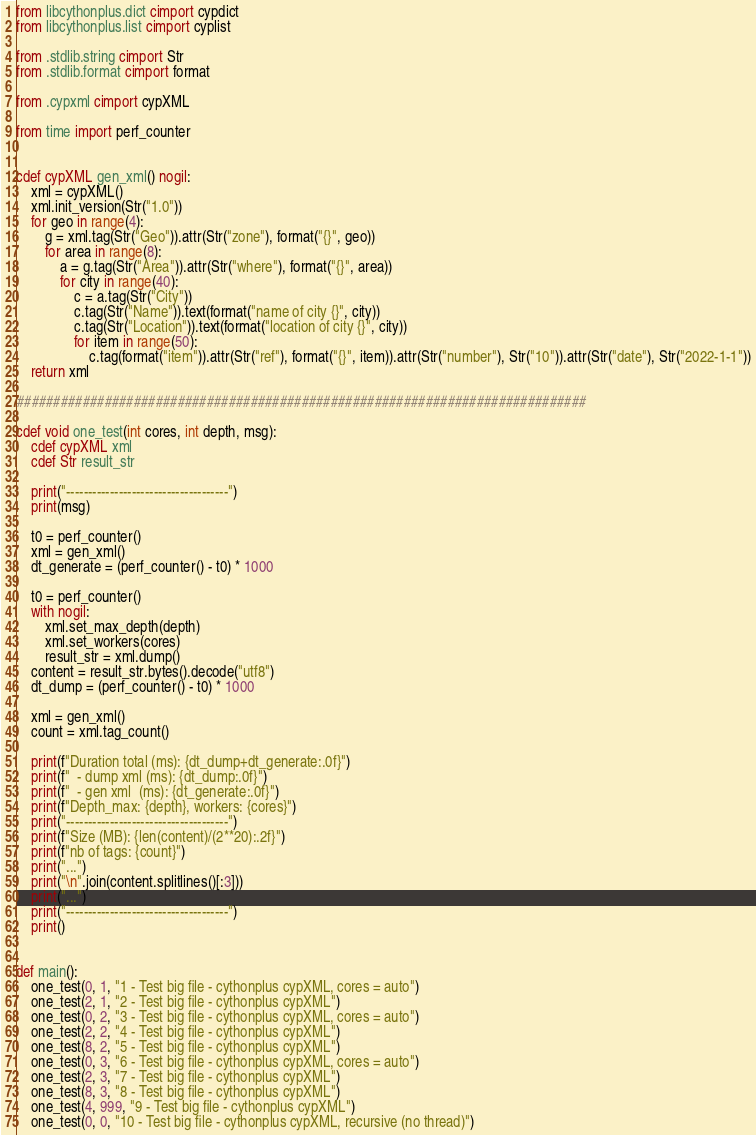Convert code to text. <code><loc_0><loc_0><loc_500><loc_500><_Cython_>from libcythonplus.dict cimport cypdict
from libcythonplus.list cimport cyplist

from .stdlib.string cimport Str
from .stdlib.format cimport format

from .cypxml cimport cypXML

from time import perf_counter


cdef cypXML gen_xml() nogil:
    xml = cypXML()
    xml.init_version(Str("1.0"))
    for geo in range(4):
        g = xml.tag(Str("Geo")).attr(Str("zone"), format("{}", geo))
        for area in range(8):
            a = g.tag(Str("Area")).attr(Str("where"), format("{}", area))
            for city in range(40):
                c = a.tag(Str("City"))
                c.tag(Str("Name")).text(format("name of city {}", city))
                c.tag(Str("Location")).text(format("location of city {}", city))
                for item in range(50):
                    c.tag(format("item")).attr(Str("ref"), format("{}", item)).attr(Str("number"), Str("10")).attr(Str("date"), Str("2022-1-1"))
    return xml

##############################################################################

cdef void one_test(int cores, int depth, msg):
    cdef cypXML xml
    cdef Str result_str

    print("-------------------------------------")
    print(msg)

    t0 = perf_counter()
    xml = gen_xml()
    dt_generate = (perf_counter() - t0) * 1000

    t0 = perf_counter()
    with nogil:
        xml.set_max_depth(depth)
        xml.set_workers(cores)
        result_str = xml.dump()
    content = result_str.bytes().decode("utf8")
    dt_dump = (perf_counter() - t0) * 1000

    xml = gen_xml()
    count = xml.tag_count()

    print(f"Duration total (ms): {dt_dump+dt_generate:.0f}")
    print(f"  - dump xml (ms): {dt_dump:.0f}")
    print(f"  - gen xml  (ms): {dt_generate:.0f}")
    print(f"Depth_max: {depth}, workers: {cores}")
    print("-------------------------------------")
    print(f"Size (MB): {len(content)/(2**20):.2f}")
    print(f"nb of tags: {count}")
    print("...")
    print("\n".join(content.splitlines()[:3]))
    print("...")
    print("-------------------------------------")
    print()


def main():
    one_test(0, 1, "1 - Test big file - cythonplus cypXML, cores = auto")
    one_test(2, 1, "2 - Test big file - cythonplus cypXML")
    one_test(0, 2, "3 - Test big file - cythonplus cypXML, cores = auto")
    one_test(2, 2, "4 - Test big file - cythonplus cypXML")
    one_test(8, 2, "5 - Test big file - cythonplus cypXML")
    one_test(0, 3, "6 - Test big file - cythonplus cypXML, cores = auto")
    one_test(2, 3, "7 - Test big file - cythonplus cypXML")
    one_test(8, 3, "8 - Test big file - cythonplus cypXML")
    one_test(4, 999, "9 - Test big file - cythonplus cypXML")
    one_test(0, 0, "10 - Test big file - cythonplus cypXML, recursive (no thread)")
</code> 